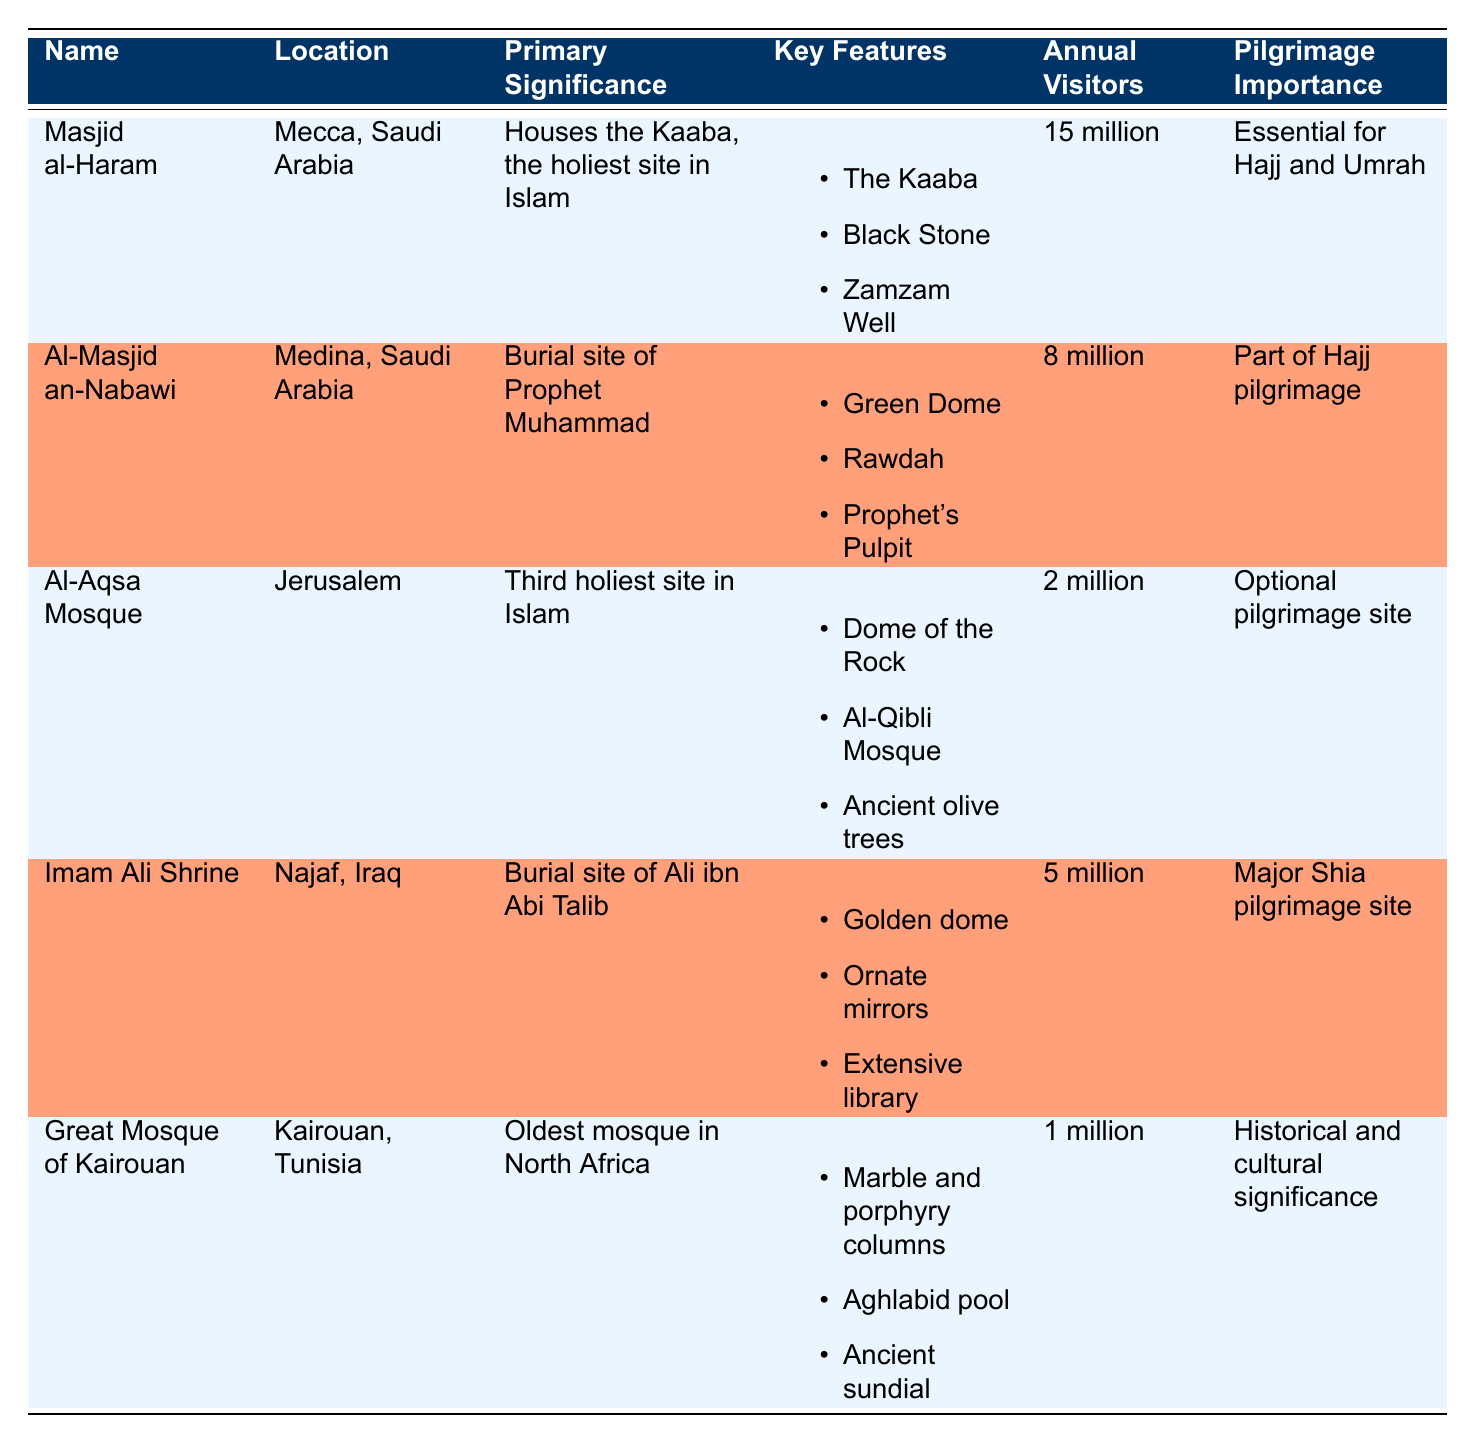What is the primary significance of Masjid al-Haram? The table indicates that the primary significance of Masjid al-Haram is that it houses the Kaaba, which is recognized as the holiest site in Islam.
Answer: Houses the Kaaba, the holiest site in Islam How many annual visitors does the Great Mosque of Kairouan have? According to the table, the Great Mosque of Kairouan has approximately 1 million annual visitors.
Answer: 1 million Is Al-Aqsa Mosque considered the third holiest site in Islam? The table states that Al-Aqsa Mosque is labeled as the third holiest site in Islam, which confirms this fact as true.
Answer: Yes What is the difference in annual visitors between Masjid al-Haram and Al-Masjid an-Nabawi? The table shows that Masjid al-Haram has 15 million annual visitors, while Al-Masjid an-Nabawi has 8 million. Thus, the difference is 15 million - 8 million = 7 million.
Answer: 7 million Which holy site has the highest pilgrimage importance? Based on the table, Masjid al-Haram is indicated as having essential pilgrimage importance for both Hajj and Umrah, making it the most significant.
Answer: Masjid al-Haram What are the key features of the Imam Ali Shrine? The table lists the key features of the Imam Ali Shrine as: 1) Golden dome, 2) Ornate mirrors, and 3) Extensive library.
Answer: Golden dome, Ornate mirrors, Extensive library What is the total number of annual visitors for Al-Masjid an-Nabawi and Imam Ali Shrine combined? From the table, Al-Masjid an-Nabawi has 8 million annual visitors and Imam Ali Shrine has 5 million. Adding them together gives 8 million + 5 million = 13 million annual visitors combined.
Answer: 13 million Does the Great Mosque of Kairouan have any significant pilgrimage importance? The table states that the Great Mosque of Kairouan has historical and cultural significance, but it does not mention pilgrimage importance, which implies the answer is no.
Answer: No What is the total number of annual visitors across all five holy sites? The annual visitors for the sites, according to the table, are: Masjid al-Haram (15 million), Al-Masjid an-Nabawi (8 million), Al-Aqsa Mosque (2 million), Imam Ali Shrine (5 million), and Great Mosque of Kairouan (1 million). Summing these gives: 15 + 8 + 2 + 5 + 1 = 31 million.
Answer: 31 million 